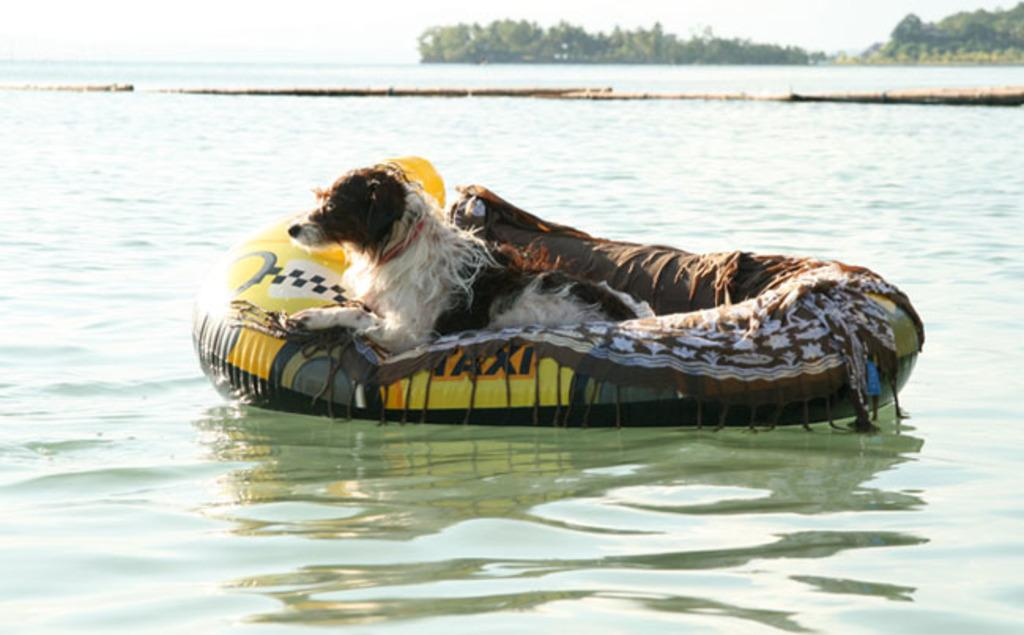What is the primary element in the image? There is water in the image. What object is present in the water? There is a tube in the water. What can be seen on the tube? A dog is present on the tube. What colors does the dog have? The dog is white and brown in color. What is visible in the background of the image? There are trees and the sky in the background of the image. What type of linen is draped over the trees in the image? There is no linen present in the image; the trees are visible without any fabric draped over them. 